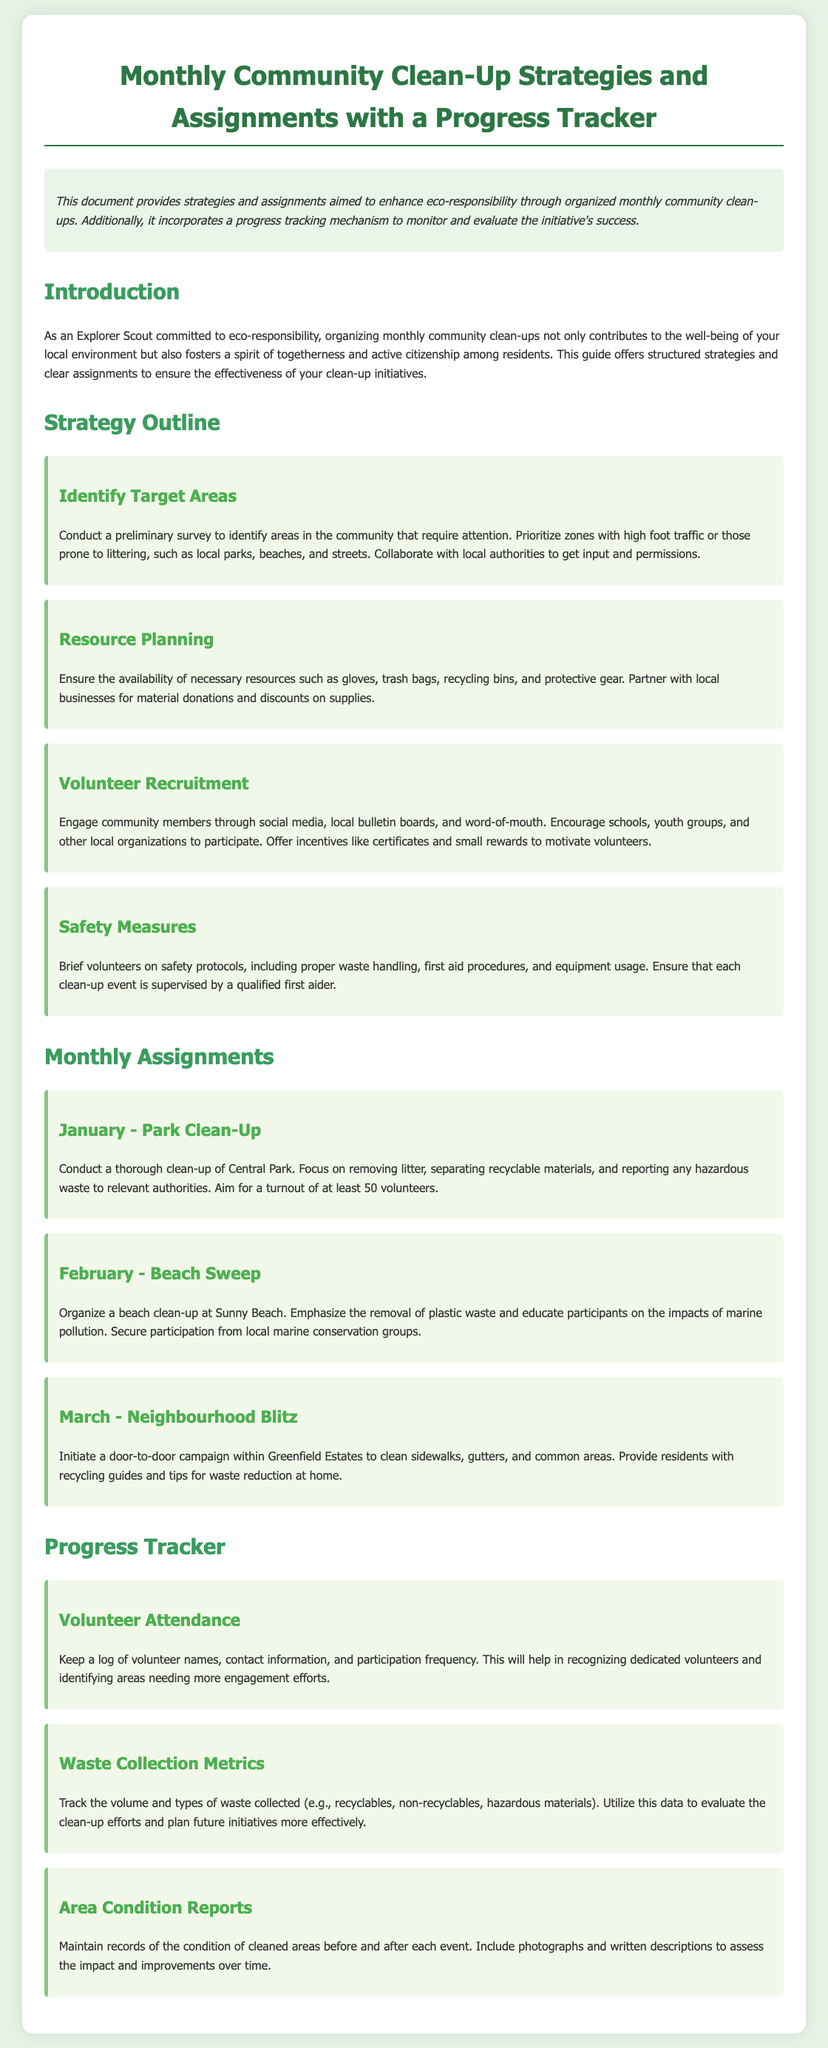What is the document title? The title of the document is stated in the header section and provides a summary of the content.
Answer: Monthly Community Clean-Up Strategies and Assignments with a Progress Tracker What month is the Park Clean-Up scheduled? The specific assignment for the Park Clean-Up can be found in the Monthly Assignments section.
Answer: January How many volunteers are aimed for the January event? The participation target for the January assignment is mentioned in the description of the assignment.
Answer: 50 What type of clean-up is planned for February? The assignment description for February explicitly states the type of clean-up planned.
Answer: Beach Sweep Which area is targeted for the March initiative? The location for the March clean-up initiative is specified in the assignment section of the document.
Answer: Greenfield Estates What safety aspect is emphasized in the strategies? The safety protocols that volunteers need to be briefed on can be found under safety measures in the strategies outline.
Answer: Safety protocols What metrics are tracked for waste collection? The types of data tracked for waste collection can be found in the Progress Tracker section.
Answer: Volume and types of waste collected What is one of the purposes of this document? The purpose of the document is summarized in the introductory section that describes its intended goals.
Answer: Enhance eco-responsibility What collaborative opportunity is suggested for Resource Planning? The details about collaboration for resources can be found in the strategy section regarding resource planning.
Answer: Partner with local businesses 